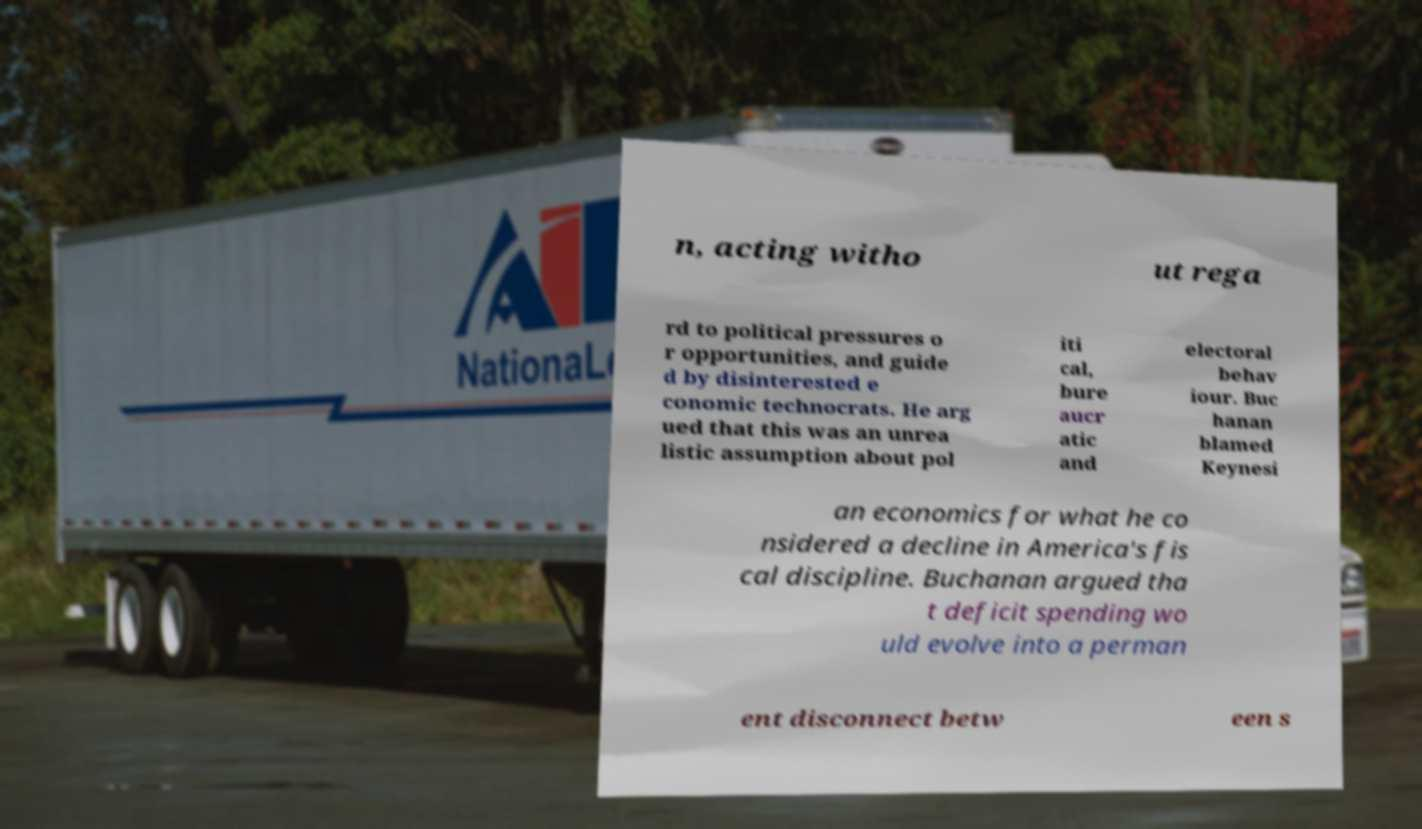I need the written content from this picture converted into text. Can you do that? n, acting witho ut rega rd to political pressures o r opportunities, and guide d by disinterested e conomic technocrats. He arg ued that this was an unrea listic assumption about pol iti cal, bure aucr atic and electoral behav iour. Buc hanan blamed Keynesi an economics for what he co nsidered a decline in America's fis cal discipline. Buchanan argued tha t deficit spending wo uld evolve into a perman ent disconnect betw een s 